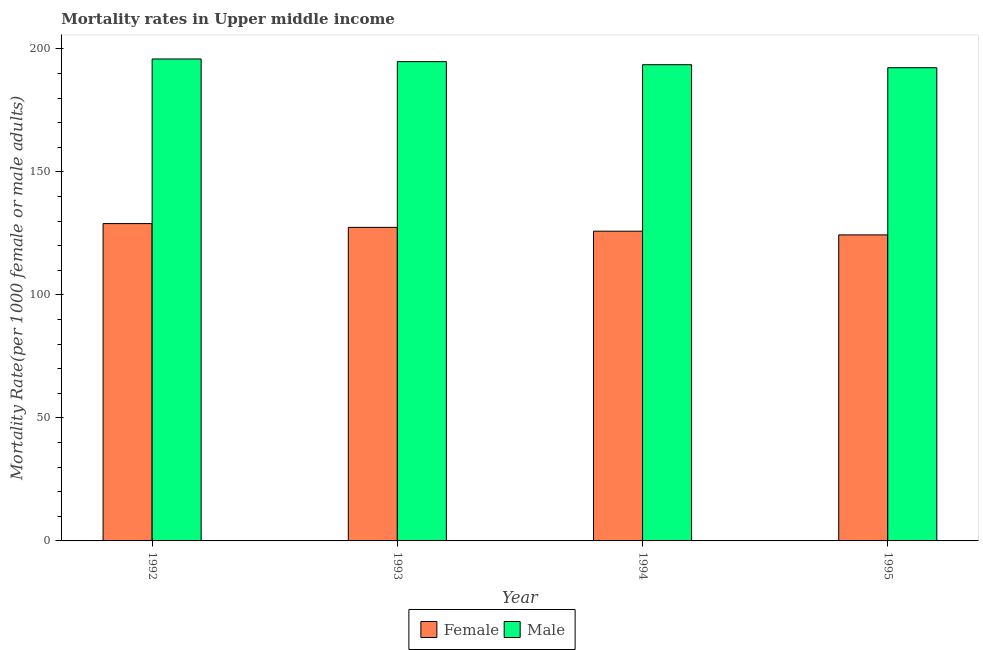How many groups of bars are there?
Ensure brevity in your answer.  4. Are the number of bars per tick equal to the number of legend labels?
Offer a terse response. Yes. How many bars are there on the 4th tick from the left?
Ensure brevity in your answer.  2. How many bars are there on the 3rd tick from the right?
Make the answer very short. 2. In how many cases, is the number of bars for a given year not equal to the number of legend labels?
Keep it short and to the point. 0. What is the female mortality rate in 1993?
Offer a very short reply. 127.45. Across all years, what is the maximum male mortality rate?
Give a very brief answer. 195.9. Across all years, what is the minimum female mortality rate?
Keep it short and to the point. 124.39. In which year was the male mortality rate maximum?
Your response must be concise. 1992. What is the total female mortality rate in the graph?
Provide a short and direct response. 506.73. What is the difference between the female mortality rate in 1992 and that in 1993?
Keep it short and to the point. 1.54. What is the difference between the female mortality rate in 1994 and the male mortality rate in 1995?
Make the answer very short. 1.51. What is the average male mortality rate per year?
Ensure brevity in your answer.  194.16. In the year 1993, what is the difference between the male mortality rate and female mortality rate?
Keep it short and to the point. 0. In how many years, is the female mortality rate greater than 100?
Make the answer very short. 4. What is the ratio of the female mortality rate in 1993 to that in 1994?
Provide a succinct answer. 1.01. What is the difference between the highest and the second highest male mortality rate?
Give a very brief answer. 1.08. What is the difference between the highest and the lowest female mortality rate?
Give a very brief answer. 4.59. Is the sum of the male mortality rate in 1992 and 1994 greater than the maximum female mortality rate across all years?
Make the answer very short. Yes. What does the 2nd bar from the left in 1994 represents?
Provide a short and direct response. Male. How many bars are there?
Your response must be concise. 8. What is the difference between two consecutive major ticks on the Y-axis?
Your answer should be compact. 50. Does the graph contain any zero values?
Your answer should be very brief. No. Does the graph contain grids?
Your answer should be compact. No. Where does the legend appear in the graph?
Make the answer very short. Bottom center. What is the title of the graph?
Provide a succinct answer. Mortality rates in Upper middle income. Does "Merchandise imports" appear as one of the legend labels in the graph?
Ensure brevity in your answer.  No. What is the label or title of the X-axis?
Keep it short and to the point. Year. What is the label or title of the Y-axis?
Your response must be concise. Mortality Rate(per 1000 female or male adults). What is the Mortality Rate(per 1000 female or male adults) in Female in 1992?
Make the answer very short. 128.99. What is the Mortality Rate(per 1000 female or male adults) of Male in 1992?
Keep it short and to the point. 195.9. What is the Mortality Rate(per 1000 female or male adults) in Female in 1993?
Your answer should be very brief. 127.45. What is the Mortality Rate(per 1000 female or male adults) in Male in 1993?
Give a very brief answer. 194.82. What is the Mortality Rate(per 1000 female or male adults) of Female in 1994?
Provide a short and direct response. 125.9. What is the Mortality Rate(per 1000 female or male adults) in Male in 1994?
Provide a short and direct response. 193.57. What is the Mortality Rate(per 1000 female or male adults) of Female in 1995?
Your answer should be very brief. 124.39. What is the Mortality Rate(per 1000 female or male adults) in Male in 1995?
Keep it short and to the point. 192.35. Across all years, what is the maximum Mortality Rate(per 1000 female or male adults) of Female?
Your answer should be very brief. 128.99. Across all years, what is the maximum Mortality Rate(per 1000 female or male adults) of Male?
Offer a terse response. 195.9. Across all years, what is the minimum Mortality Rate(per 1000 female or male adults) in Female?
Make the answer very short. 124.39. Across all years, what is the minimum Mortality Rate(per 1000 female or male adults) of Male?
Your answer should be compact. 192.35. What is the total Mortality Rate(per 1000 female or male adults) in Female in the graph?
Give a very brief answer. 506.73. What is the total Mortality Rate(per 1000 female or male adults) in Male in the graph?
Give a very brief answer. 776.64. What is the difference between the Mortality Rate(per 1000 female or male adults) of Female in 1992 and that in 1993?
Provide a short and direct response. 1.54. What is the difference between the Mortality Rate(per 1000 female or male adults) of Male in 1992 and that in 1993?
Keep it short and to the point. 1.08. What is the difference between the Mortality Rate(per 1000 female or male adults) of Female in 1992 and that in 1994?
Your response must be concise. 3.08. What is the difference between the Mortality Rate(per 1000 female or male adults) in Male in 1992 and that in 1994?
Provide a short and direct response. 2.33. What is the difference between the Mortality Rate(per 1000 female or male adults) of Female in 1992 and that in 1995?
Ensure brevity in your answer.  4.59. What is the difference between the Mortality Rate(per 1000 female or male adults) in Male in 1992 and that in 1995?
Ensure brevity in your answer.  3.55. What is the difference between the Mortality Rate(per 1000 female or male adults) in Female in 1993 and that in 1994?
Give a very brief answer. 1.55. What is the difference between the Mortality Rate(per 1000 female or male adults) in Male in 1993 and that in 1994?
Provide a short and direct response. 1.25. What is the difference between the Mortality Rate(per 1000 female or male adults) in Female in 1993 and that in 1995?
Keep it short and to the point. 3.06. What is the difference between the Mortality Rate(per 1000 female or male adults) of Male in 1993 and that in 1995?
Provide a succinct answer. 2.47. What is the difference between the Mortality Rate(per 1000 female or male adults) in Female in 1994 and that in 1995?
Provide a succinct answer. 1.51. What is the difference between the Mortality Rate(per 1000 female or male adults) in Male in 1994 and that in 1995?
Offer a terse response. 1.22. What is the difference between the Mortality Rate(per 1000 female or male adults) in Female in 1992 and the Mortality Rate(per 1000 female or male adults) in Male in 1993?
Make the answer very short. -65.83. What is the difference between the Mortality Rate(per 1000 female or male adults) in Female in 1992 and the Mortality Rate(per 1000 female or male adults) in Male in 1994?
Ensure brevity in your answer.  -64.59. What is the difference between the Mortality Rate(per 1000 female or male adults) in Female in 1992 and the Mortality Rate(per 1000 female or male adults) in Male in 1995?
Your answer should be very brief. -63.36. What is the difference between the Mortality Rate(per 1000 female or male adults) of Female in 1993 and the Mortality Rate(per 1000 female or male adults) of Male in 1994?
Your answer should be very brief. -66.12. What is the difference between the Mortality Rate(per 1000 female or male adults) in Female in 1993 and the Mortality Rate(per 1000 female or male adults) in Male in 1995?
Your answer should be compact. -64.9. What is the difference between the Mortality Rate(per 1000 female or male adults) of Female in 1994 and the Mortality Rate(per 1000 female or male adults) of Male in 1995?
Your response must be concise. -66.45. What is the average Mortality Rate(per 1000 female or male adults) of Female per year?
Your response must be concise. 126.68. What is the average Mortality Rate(per 1000 female or male adults) in Male per year?
Give a very brief answer. 194.16. In the year 1992, what is the difference between the Mortality Rate(per 1000 female or male adults) in Female and Mortality Rate(per 1000 female or male adults) in Male?
Your answer should be very brief. -66.91. In the year 1993, what is the difference between the Mortality Rate(per 1000 female or male adults) in Female and Mortality Rate(per 1000 female or male adults) in Male?
Provide a succinct answer. -67.37. In the year 1994, what is the difference between the Mortality Rate(per 1000 female or male adults) in Female and Mortality Rate(per 1000 female or male adults) in Male?
Provide a short and direct response. -67.67. In the year 1995, what is the difference between the Mortality Rate(per 1000 female or male adults) in Female and Mortality Rate(per 1000 female or male adults) in Male?
Your answer should be compact. -67.96. What is the ratio of the Mortality Rate(per 1000 female or male adults) in Female in 1992 to that in 1993?
Make the answer very short. 1.01. What is the ratio of the Mortality Rate(per 1000 female or male adults) in Female in 1992 to that in 1994?
Offer a very short reply. 1.02. What is the ratio of the Mortality Rate(per 1000 female or male adults) in Male in 1992 to that in 1994?
Offer a very short reply. 1.01. What is the ratio of the Mortality Rate(per 1000 female or male adults) of Female in 1992 to that in 1995?
Make the answer very short. 1.04. What is the ratio of the Mortality Rate(per 1000 female or male adults) of Male in 1992 to that in 1995?
Ensure brevity in your answer.  1.02. What is the ratio of the Mortality Rate(per 1000 female or male adults) of Female in 1993 to that in 1994?
Give a very brief answer. 1.01. What is the ratio of the Mortality Rate(per 1000 female or male adults) of Male in 1993 to that in 1994?
Offer a very short reply. 1.01. What is the ratio of the Mortality Rate(per 1000 female or male adults) in Female in 1993 to that in 1995?
Give a very brief answer. 1.02. What is the ratio of the Mortality Rate(per 1000 female or male adults) in Male in 1993 to that in 1995?
Your answer should be very brief. 1.01. What is the ratio of the Mortality Rate(per 1000 female or male adults) in Female in 1994 to that in 1995?
Make the answer very short. 1.01. What is the ratio of the Mortality Rate(per 1000 female or male adults) in Male in 1994 to that in 1995?
Your answer should be compact. 1.01. What is the difference between the highest and the second highest Mortality Rate(per 1000 female or male adults) in Female?
Ensure brevity in your answer.  1.54. What is the difference between the highest and the second highest Mortality Rate(per 1000 female or male adults) of Male?
Your answer should be very brief. 1.08. What is the difference between the highest and the lowest Mortality Rate(per 1000 female or male adults) of Female?
Ensure brevity in your answer.  4.59. What is the difference between the highest and the lowest Mortality Rate(per 1000 female or male adults) in Male?
Offer a very short reply. 3.55. 